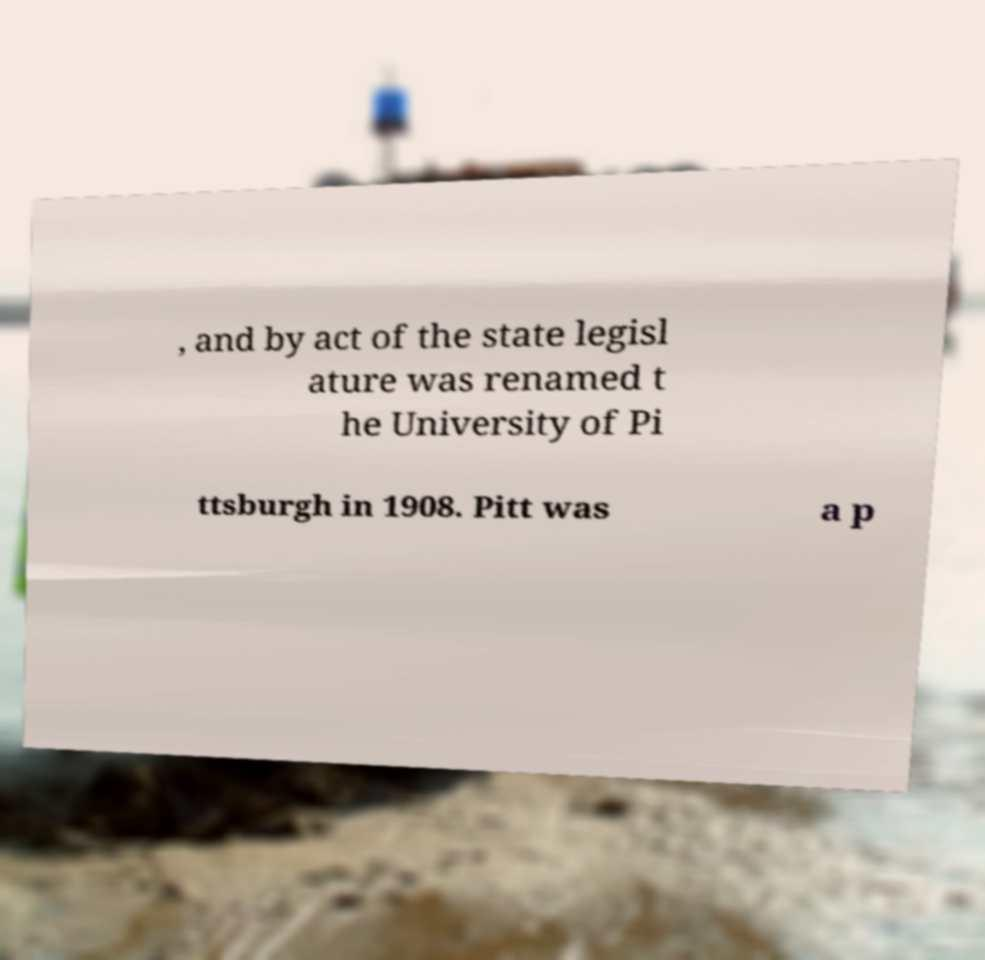Could you assist in decoding the text presented in this image and type it out clearly? , and by act of the state legisl ature was renamed t he University of Pi ttsburgh in 1908. Pitt was a p 